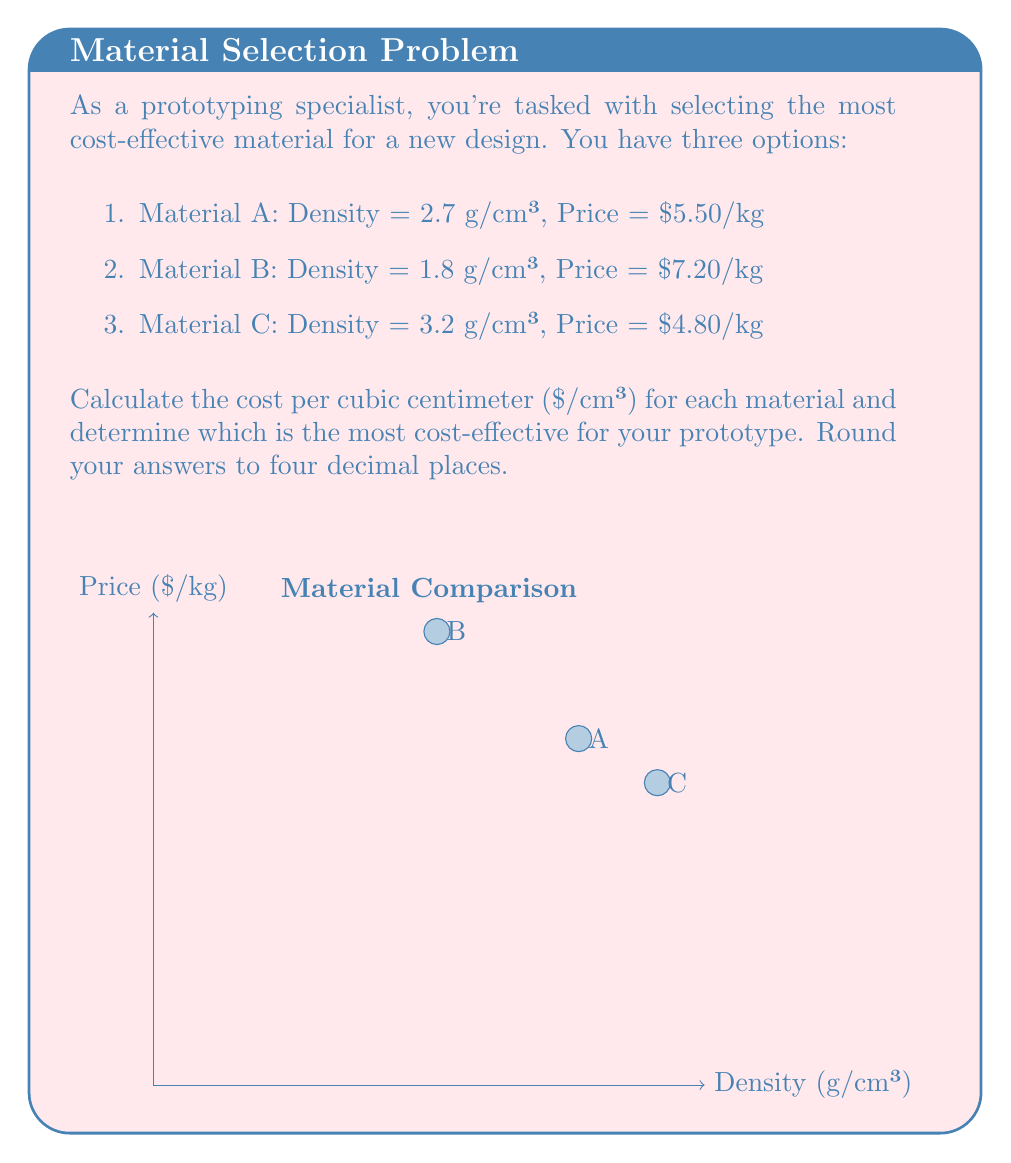What is the answer to this math problem? To solve this problem, we need to calculate the cost per cubic centimeter for each material. We'll use the formula:

$$ \text{Cost per cm³} = \frac{\text{Price per kg}}{\text{Density in g/cm³}} \times \frac{1}{1000} $$

The factor of 1/1000 is used to convert from kg to g.

For Material A:
$$ \text{Cost per cm³} = \frac{5.50}{2.7} \times \frac{1}{1000} = 0.002037 \text{ $/cm³} $$

For Material B:
$$ \text{Cost per cm³} = \frac{7.20}{1.8} \times \frac{1}{1000} = 0.004000 \text{ $/cm³} $$

For Material C:
$$ \text{Cost per cm³} = \frac{4.80}{3.2} \times \frac{1}{1000} = 0.001500 \text{ $/cm³} $$

Rounding to four decimal places:
Material A: $0.0020 \text{ $/cm³}$
Material B: $0.0040 \text{ $/cm³}$
Material C: $0.0015 \text{ $/cm³}$

Comparing these values, we can see that Material C has the lowest cost per cubic centimeter, making it the most cost-effective option for the prototype.
Answer: Material C at $0.0015/cm³ 